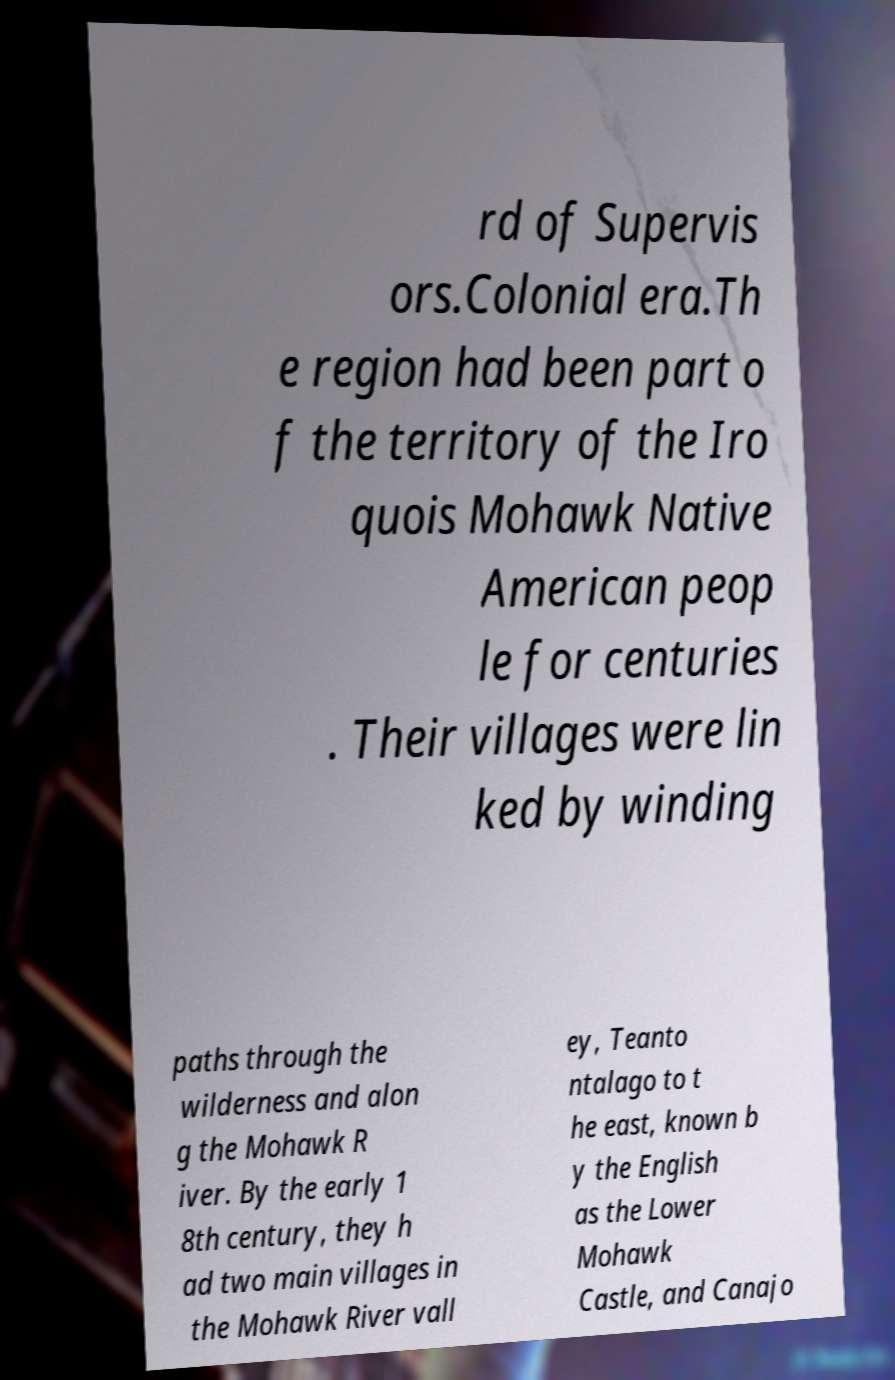Can you read and provide the text displayed in the image?This photo seems to have some interesting text. Can you extract and type it out for me? rd of Supervis ors.Colonial era.Th e region had been part o f the territory of the Iro quois Mohawk Native American peop le for centuries . Their villages were lin ked by winding paths through the wilderness and alon g the Mohawk R iver. By the early 1 8th century, they h ad two main villages in the Mohawk River vall ey, Teanto ntalago to t he east, known b y the English as the Lower Mohawk Castle, and Canajo 